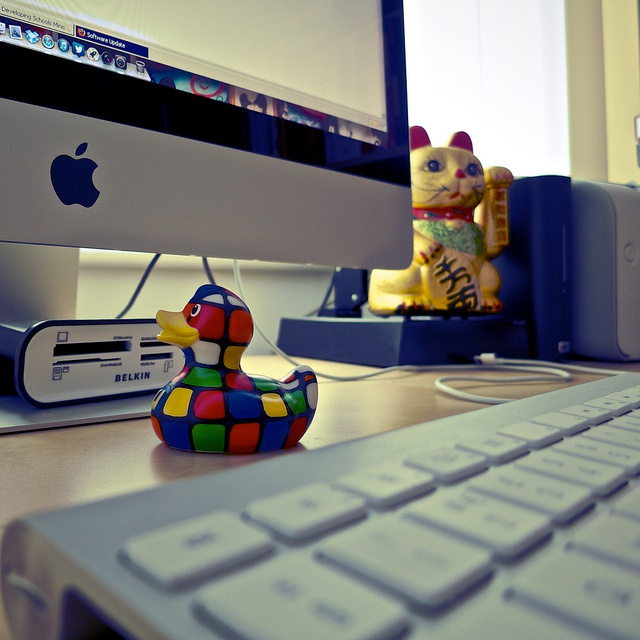Describe the objects in this image and their specific colors. I can see tv in lightgray, gray, black, beige, and darkgray tones and keyboard in lightgray, darkgray, and gray tones in this image. 